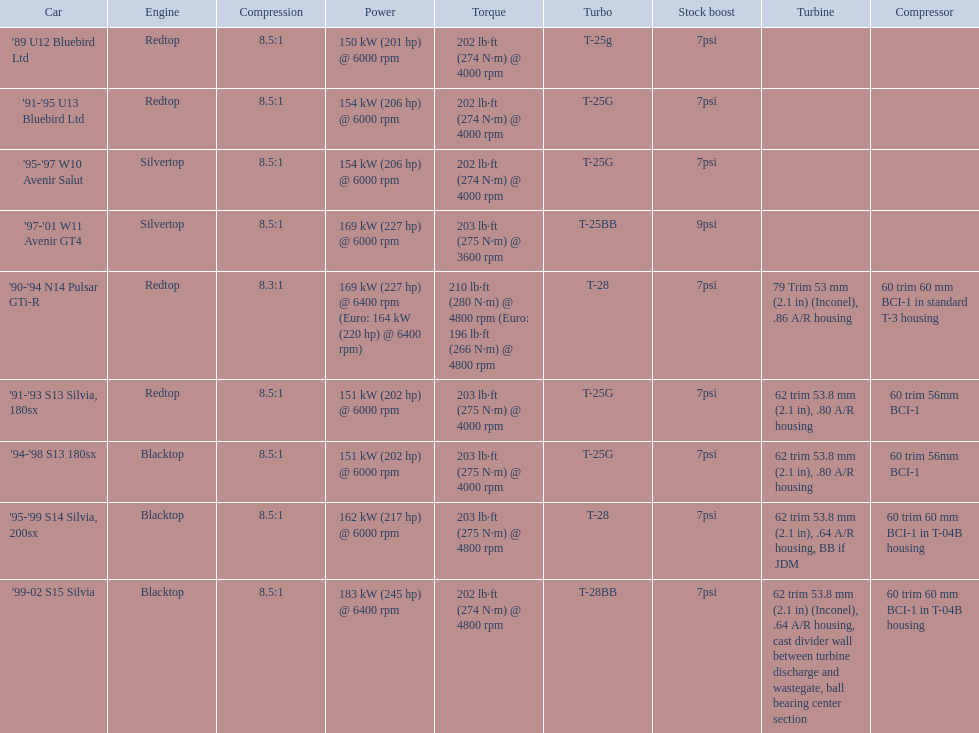Which vehicles include turbine information? '90-'94 N14 Pulsar GTi-R, '91-'93 S13 Silvia, 180sx, '94-'98 S13 180sx, '95-'99 S14 Silvia, 200sx, '99-02 S15 Silvia. Which of these achieve their peak horsepower at the highest rpm? '90-'94 N14 Pulsar GTi-R, '99-02 S15 Silvia. Among those, what is the compression of the only non-blacktop engine? 8.3:1. 